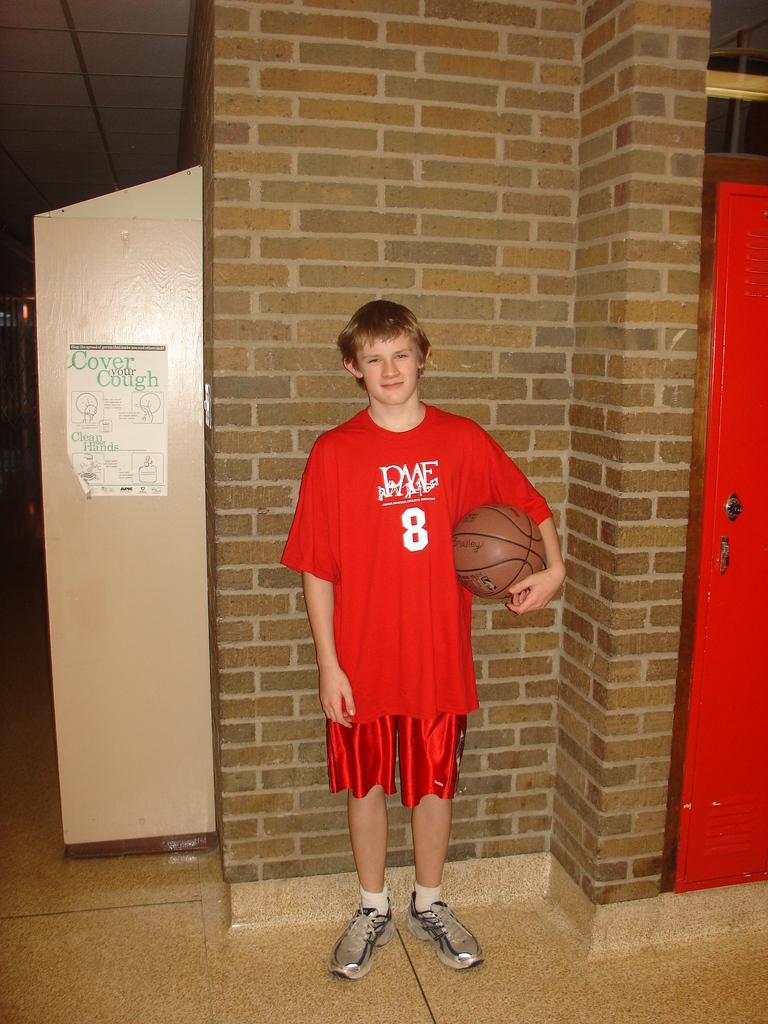What are the initials on the shirt?
Provide a succinct answer. Pme. 